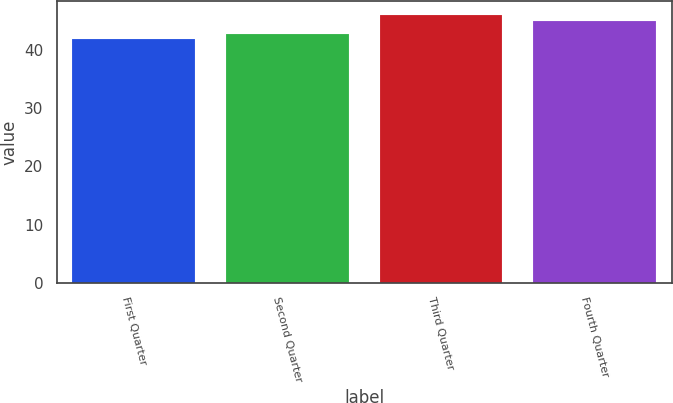Convert chart. <chart><loc_0><loc_0><loc_500><loc_500><bar_chart><fcel>First Quarter<fcel>Second Quarter<fcel>Third Quarter<fcel>Fourth Quarter<nl><fcel>41.93<fcel>42.81<fcel>46.02<fcel>44.91<nl></chart> 